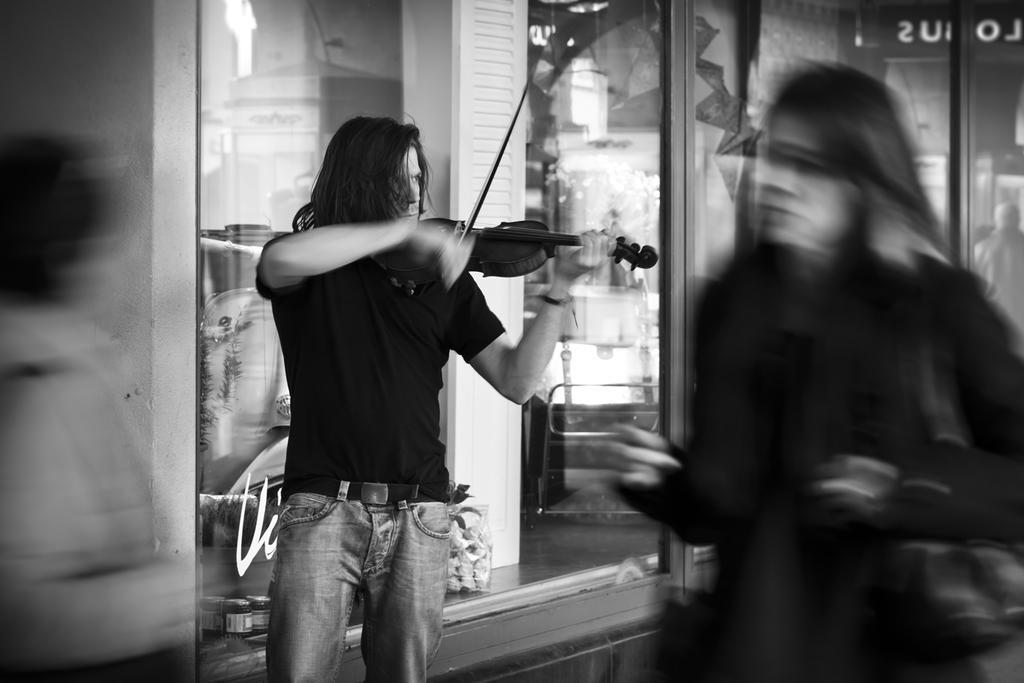Please provide a concise description of this image. This is the blurred picture where we have a guy wearing black shirt and holding the guitar and playing it. 